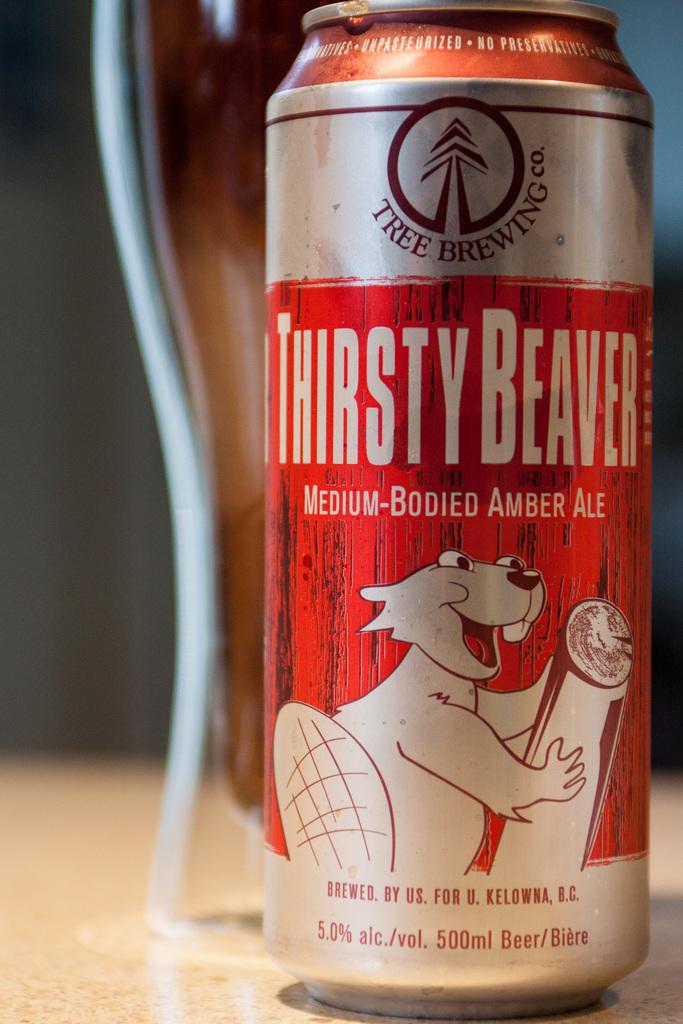What is the name of the beverage?
Offer a very short reply. Thirsty beaver. 